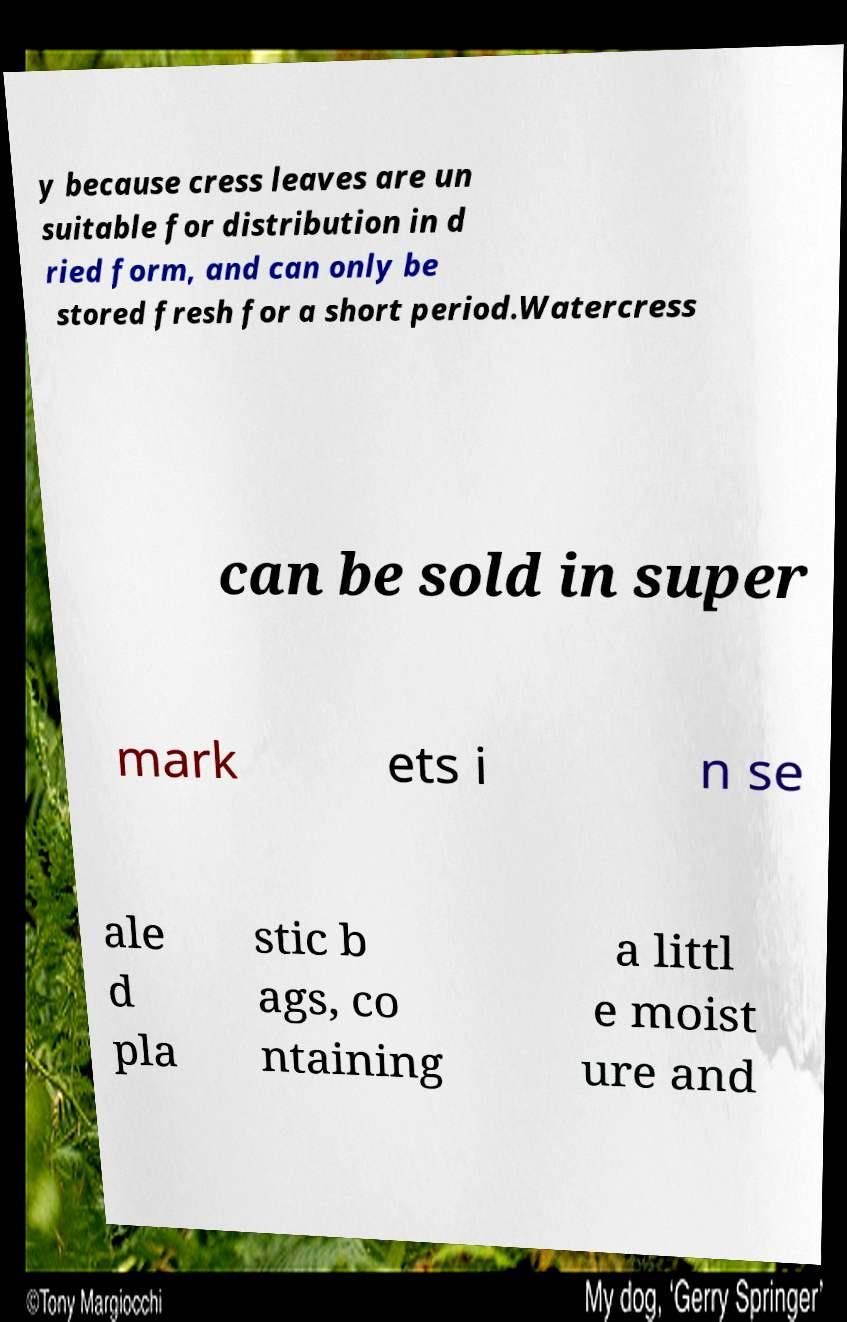Can you read and provide the text displayed in the image?This photo seems to have some interesting text. Can you extract and type it out for me? y because cress leaves are un suitable for distribution in d ried form, and can only be stored fresh for a short period.Watercress can be sold in super mark ets i n se ale d pla stic b ags, co ntaining a littl e moist ure and 